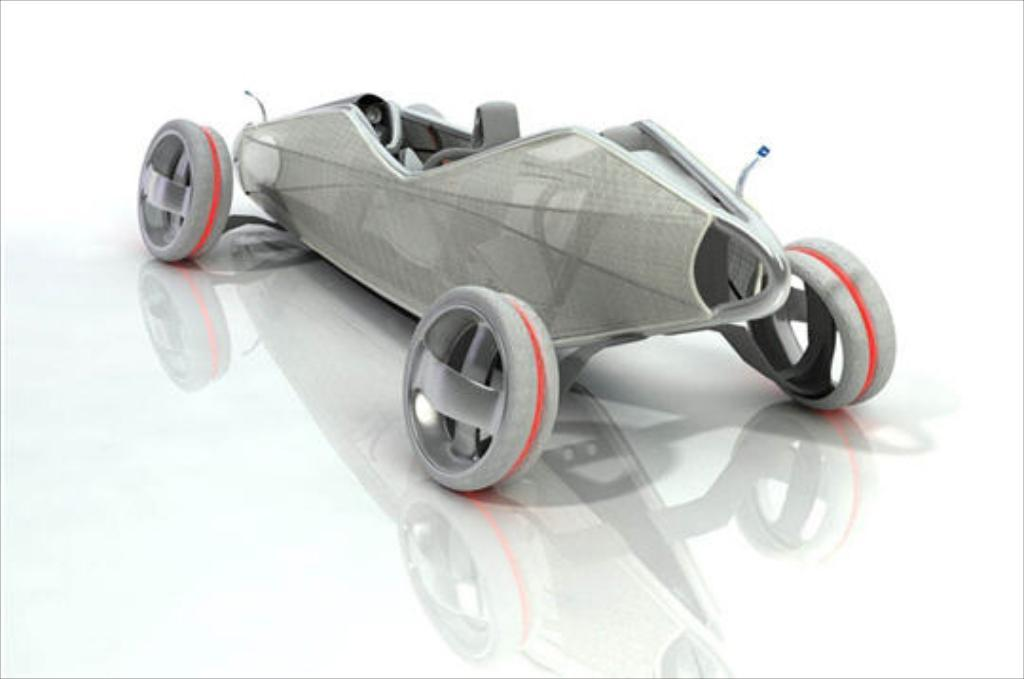What is the main subject of the image? There is a concept car in the image. Where is the concept car located in the image? The concept car is in the center of the image. What type of curtain is hanging on the side of the concept car in the image? There is no curtain present in the image; it only features a concept car in the center. 